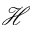<formula> <loc_0><loc_0><loc_500><loc_500>\mathcal { H }</formula> 